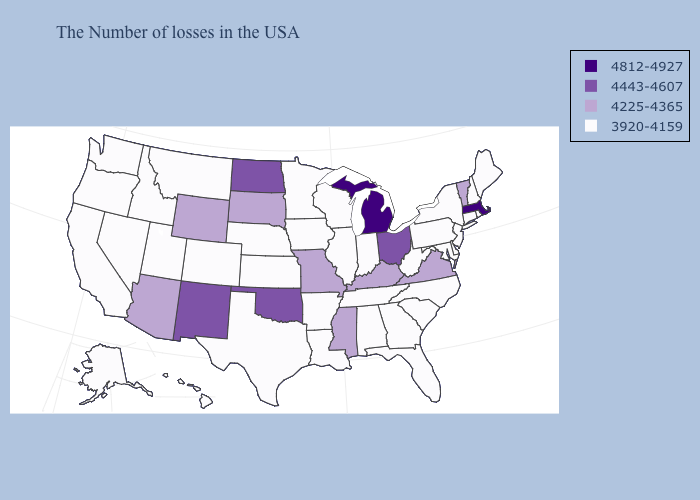What is the highest value in the USA?
Give a very brief answer. 4812-4927. What is the highest value in the USA?
Write a very short answer. 4812-4927. Among the states that border Oklahoma , which have the highest value?
Concise answer only. New Mexico. Name the states that have a value in the range 4443-4607?
Answer briefly. Ohio, Oklahoma, North Dakota, New Mexico. Name the states that have a value in the range 4812-4927?
Concise answer only. Massachusetts, Michigan. Does New Mexico have the highest value in the West?
Write a very short answer. Yes. Does Alabama have a lower value than Vermont?
Concise answer only. Yes. Name the states that have a value in the range 3920-4159?
Give a very brief answer. Maine, Rhode Island, New Hampshire, Connecticut, New York, New Jersey, Delaware, Maryland, Pennsylvania, North Carolina, South Carolina, West Virginia, Florida, Georgia, Indiana, Alabama, Tennessee, Wisconsin, Illinois, Louisiana, Arkansas, Minnesota, Iowa, Kansas, Nebraska, Texas, Colorado, Utah, Montana, Idaho, Nevada, California, Washington, Oregon, Alaska, Hawaii. Name the states that have a value in the range 3920-4159?
Quick response, please. Maine, Rhode Island, New Hampshire, Connecticut, New York, New Jersey, Delaware, Maryland, Pennsylvania, North Carolina, South Carolina, West Virginia, Florida, Georgia, Indiana, Alabama, Tennessee, Wisconsin, Illinois, Louisiana, Arkansas, Minnesota, Iowa, Kansas, Nebraska, Texas, Colorado, Utah, Montana, Idaho, Nevada, California, Washington, Oregon, Alaska, Hawaii. Does Texas have the same value as Alaska?
Short answer required. Yes. Does the first symbol in the legend represent the smallest category?
Give a very brief answer. No. Name the states that have a value in the range 4812-4927?
Answer briefly. Massachusetts, Michigan. Among the states that border Minnesota , which have the highest value?
Short answer required. North Dakota. Name the states that have a value in the range 3920-4159?
Answer briefly. Maine, Rhode Island, New Hampshire, Connecticut, New York, New Jersey, Delaware, Maryland, Pennsylvania, North Carolina, South Carolina, West Virginia, Florida, Georgia, Indiana, Alabama, Tennessee, Wisconsin, Illinois, Louisiana, Arkansas, Minnesota, Iowa, Kansas, Nebraska, Texas, Colorado, Utah, Montana, Idaho, Nevada, California, Washington, Oregon, Alaska, Hawaii. What is the highest value in the MidWest ?
Quick response, please. 4812-4927. 